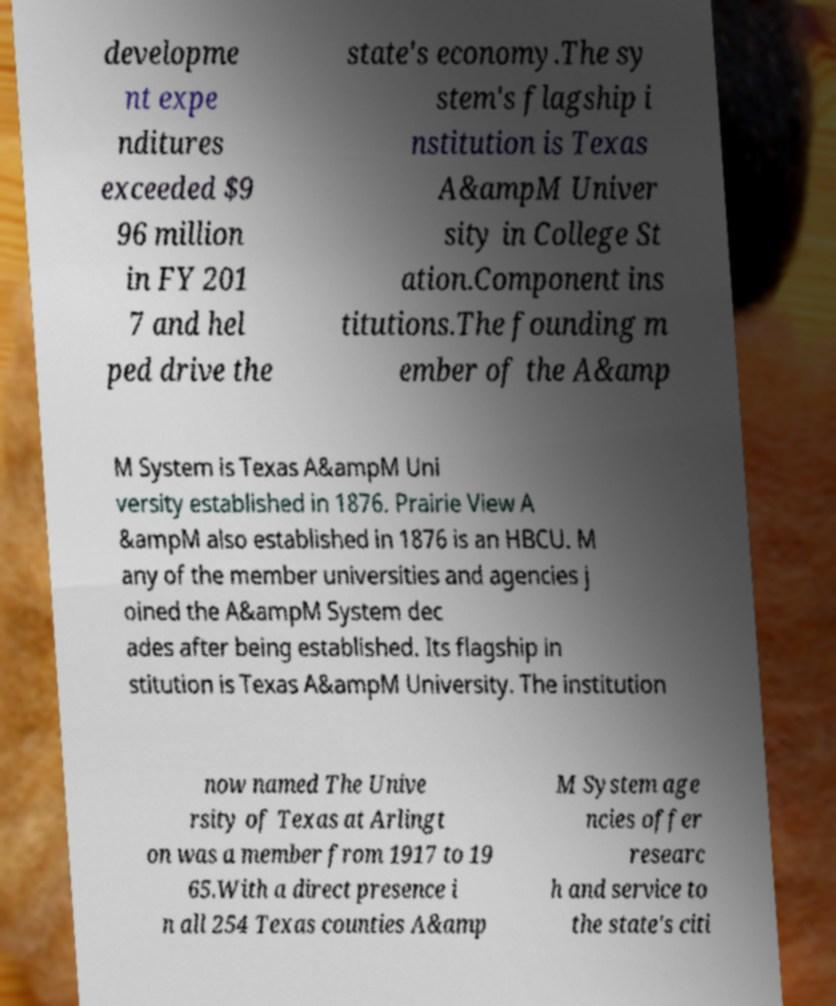Please read and relay the text visible in this image. What does it say? developme nt expe nditures exceeded $9 96 million in FY 201 7 and hel ped drive the state's economy.The sy stem's flagship i nstitution is Texas A&ampM Univer sity in College St ation.Component ins titutions.The founding m ember of the A&amp M System is Texas A&ampM Uni versity established in 1876. Prairie View A &ampM also established in 1876 is an HBCU. M any of the member universities and agencies j oined the A&ampM System dec ades after being established. Its flagship in stitution is Texas A&ampM University. The institution now named The Unive rsity of Texas at Arlingt on was a member from 1917 to 19 65.With a direct presence i n all 254 Texas counties A&amp M System age ncies offer researc h and service to the state's citi 